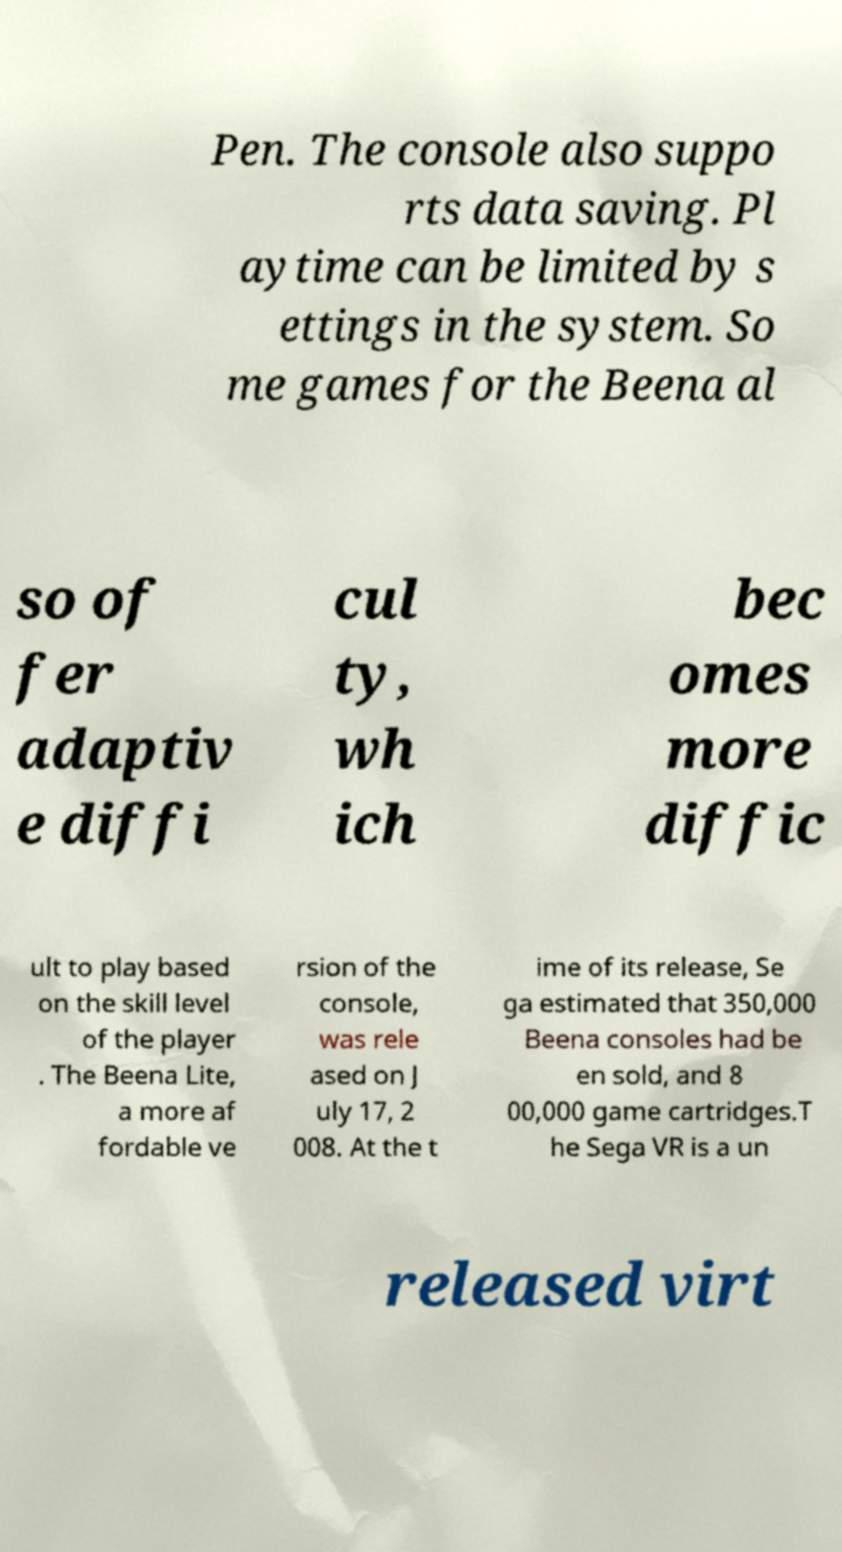Please identify and transcribe the text found in this image. Pen. The console also suppo rts data saving. Pl aytime can be limited by s ettings in the system. So me games for the Beena al so of fer adaptiv e diffi cul ty, wh ich bec omes more diffic ult to play based on the skill level of the player . The Beena Lite, a more af fordable ve rsion of the console, was rele ased on J uly 17, 2 008. At the t ime of its release, Se ga estimated that 350,000 Beena consoles had be en sold, and 8 00,000 game cartridges.T he Sega VR is a un released virt 